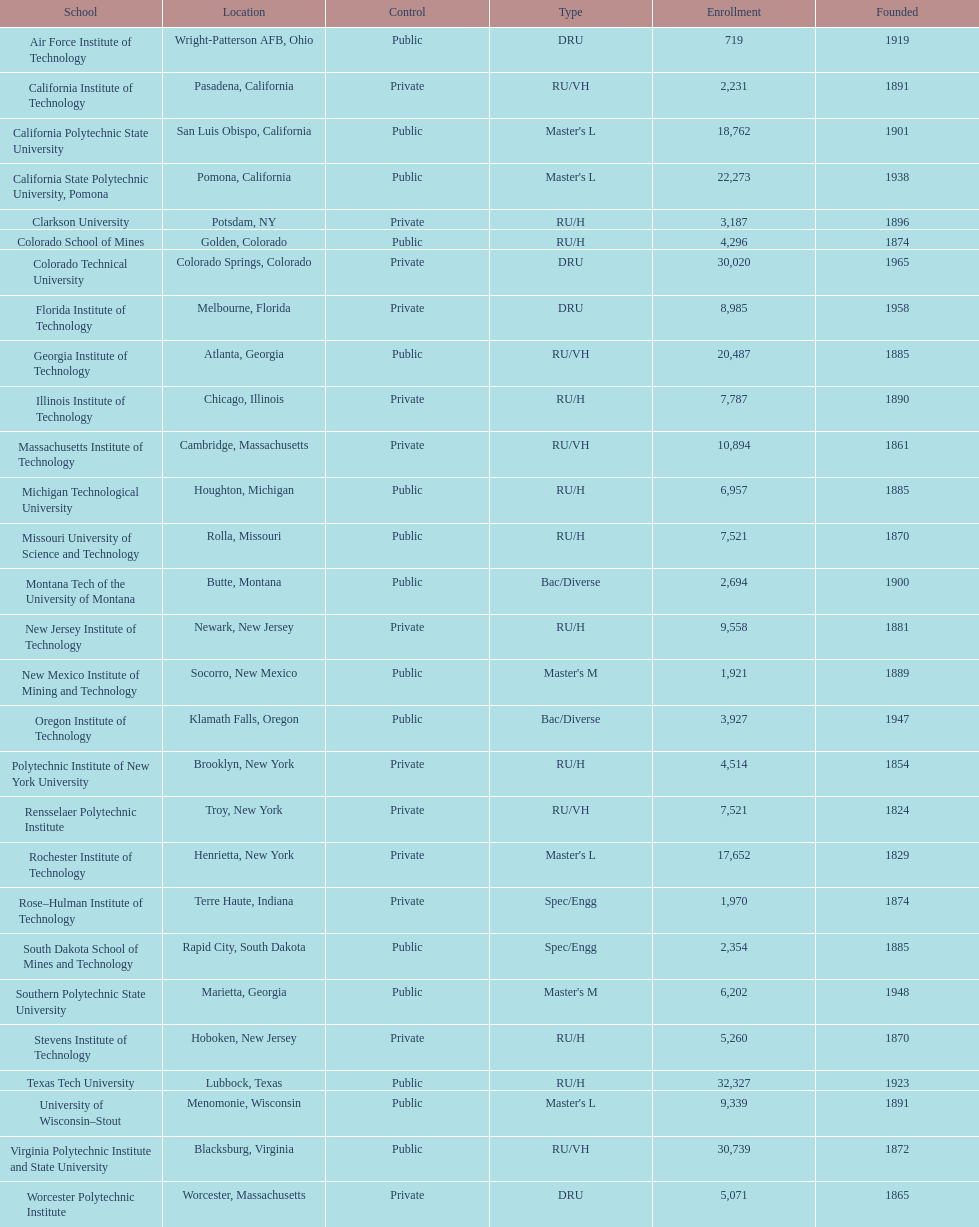What is the number of universities situated in california? 3. 